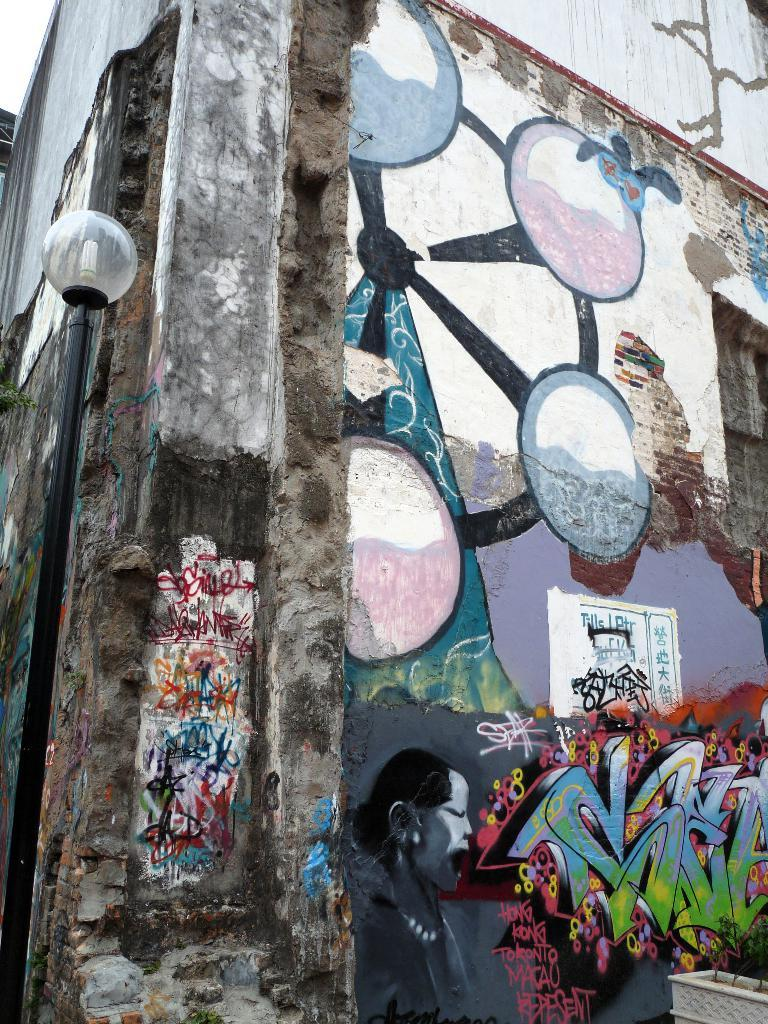What type of structure is present in the image? There is a building in the image. What is the color of the building? The building is gray in color. What else can be seen in the image besides the building? There are paintings in the image. What can be said about the colors of the paintings? The paintings have multiple colors. What other object is visible in the image? There is a pole in the image. What type of songs can be heard playing in the background of the image? There is no information about songs or any audio in the image, so it cannot be determined what songs might be heard. 